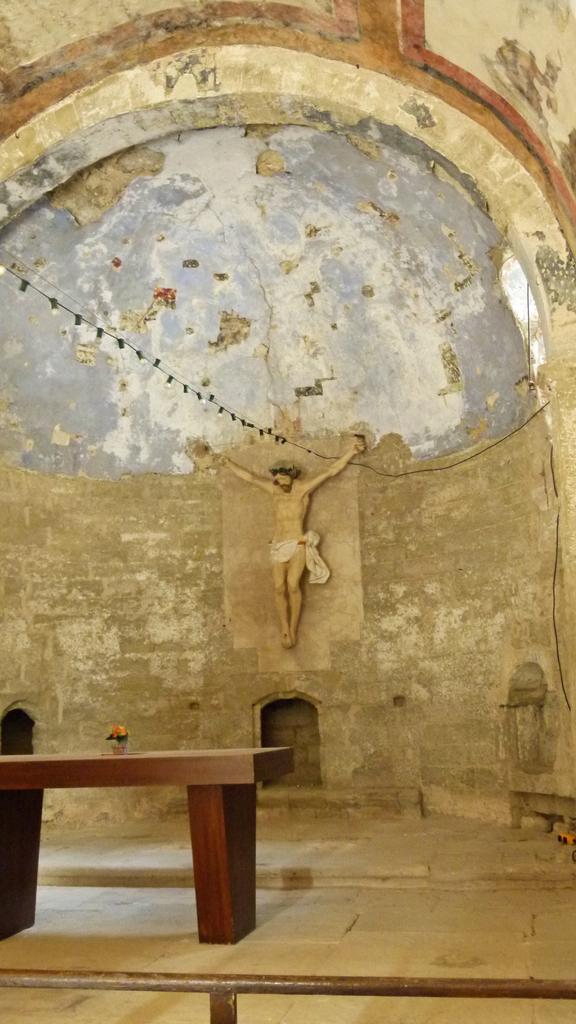How would you summarize this image in a sentence or two? At the bottom of the picture, we see the iron rod. In the middle, we see a wooden table on which an object is placed. In the middle of the picture, we see the statue of the Jesus. In the background, we see a wall which is made up of stones. This picture might be clicked in the church. 